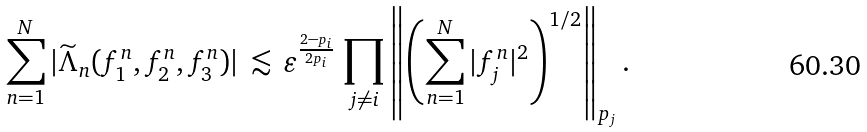<formula> <loc_0><loc_0><loc_500><loc_500>\sum _ { n = 1 } ^ { N } | \widetilde { \Lambda } _ { n } ( f _ { 1 } ^ { n } , f _ { 2 } ^ { n } , f _ { 3 } ^ { n } ) | \, \lesssim \, \varepsilon ^ { \frac { 2 - p _ { i } } { 2 p _ { i } } } \, \prod _ { j \neq i } \left \| \left ( \sum _ { n = 1 } ^ { N } | f _ { j } ^ { n } | ^ { 2 } \right ) ^ { 1 / 2 } \right \| _ { p _ { j } } .</formula> 